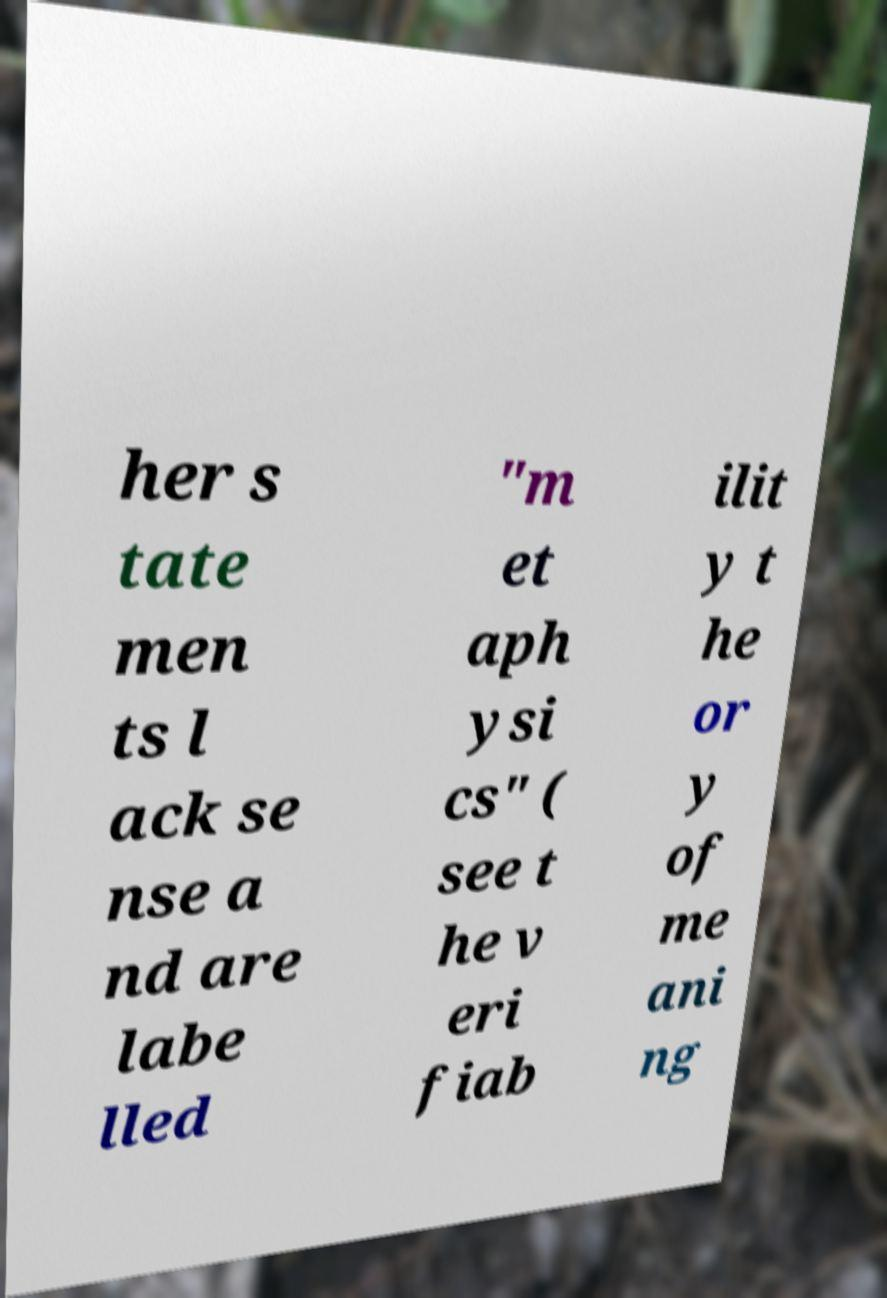Could you extract and type out the text from this image? her s tate men ts l ack se nse a nd are labe lled "m et aph ysi cs" ( see t he v eri fiab ilit y t he or y of me ani ng 